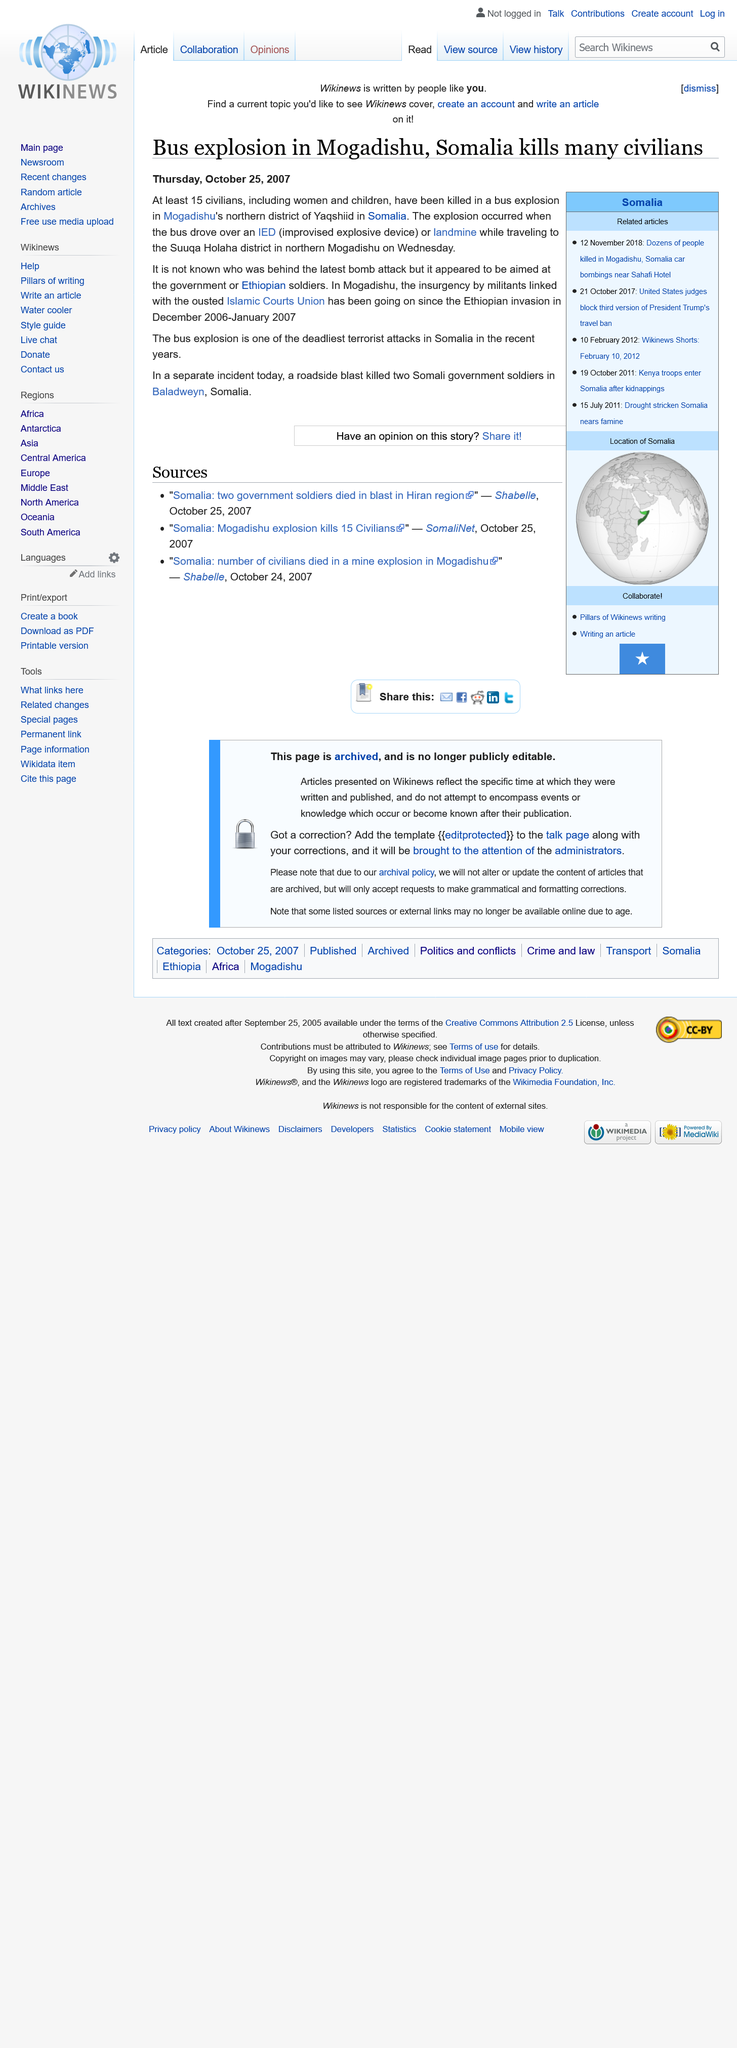Identify some key points in this picture. A roadside blast in Somalia resulted in the death of two Somali soldiers. According to the article from 25th October 2007, at least 15 civilians were killed in a bus explosion in Mogadishu. The insurgency by militants has been ongoing since December 2006 - January 2007. 